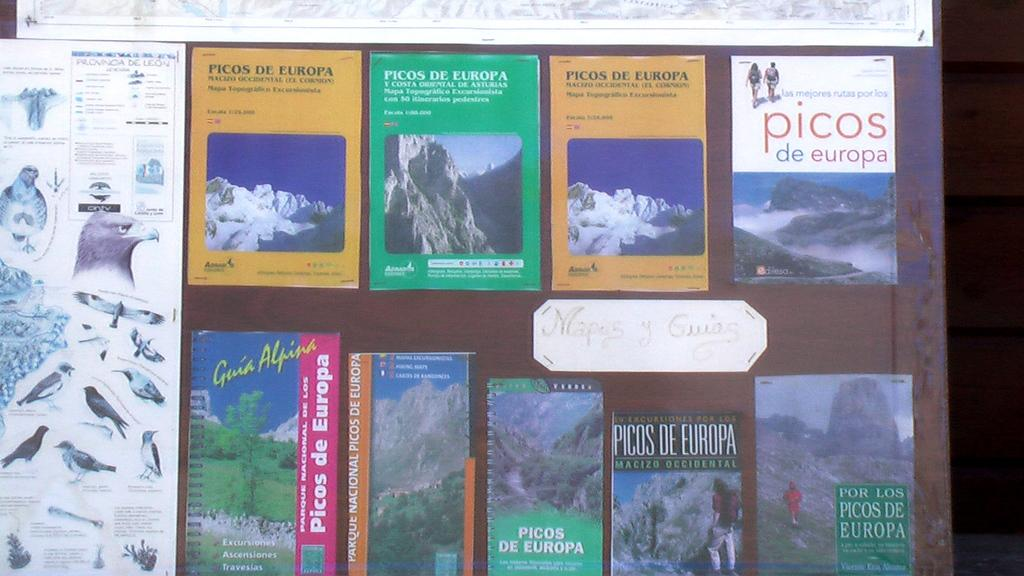<image>
Share a concise interpretation of the image provided. Different pamphlets and maps for Picos de Europe are arranged by a poster of birds. 